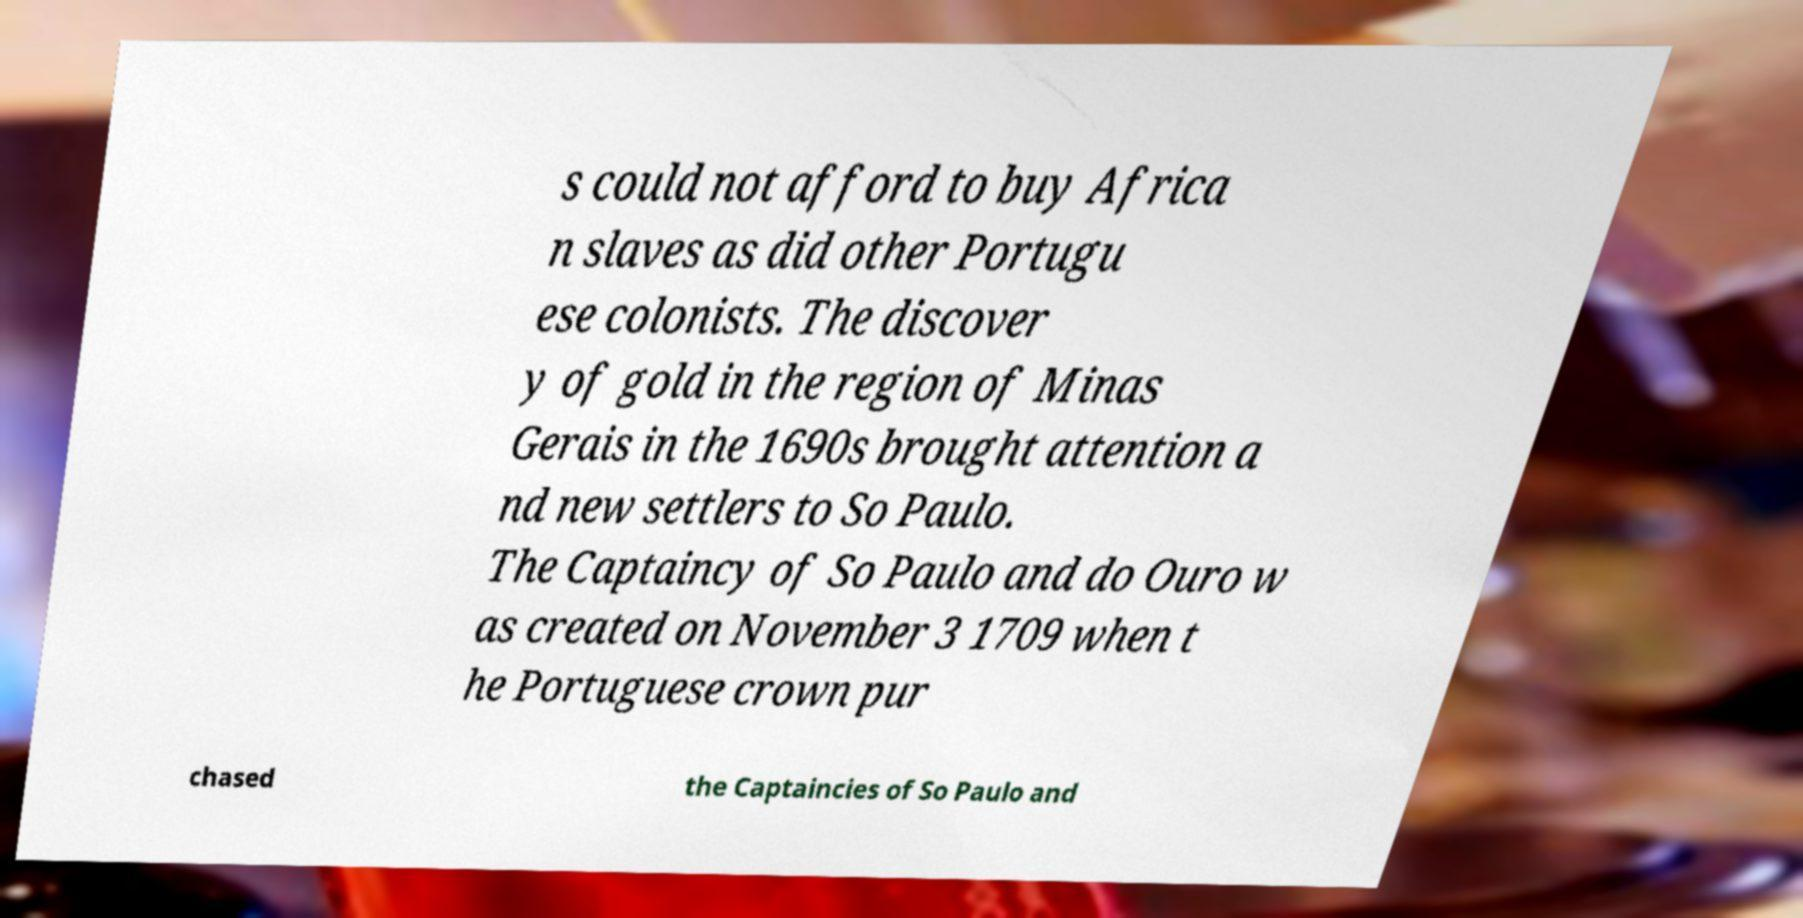There's text embedded in this image that I need extracted. Can you transcribe it verbatim? s could not afford to buy Africa n slaves as did other Portugu ese colonists. The discover y of gold in the region of Minas Gerais in the 1690s brought attention a nd new settlers to So Paulo. The Captaincy of So Paulo and do Ouro w as created on November 3 1709 when t he Portuguese crown pur chased the Captaincies of So Paulo and 